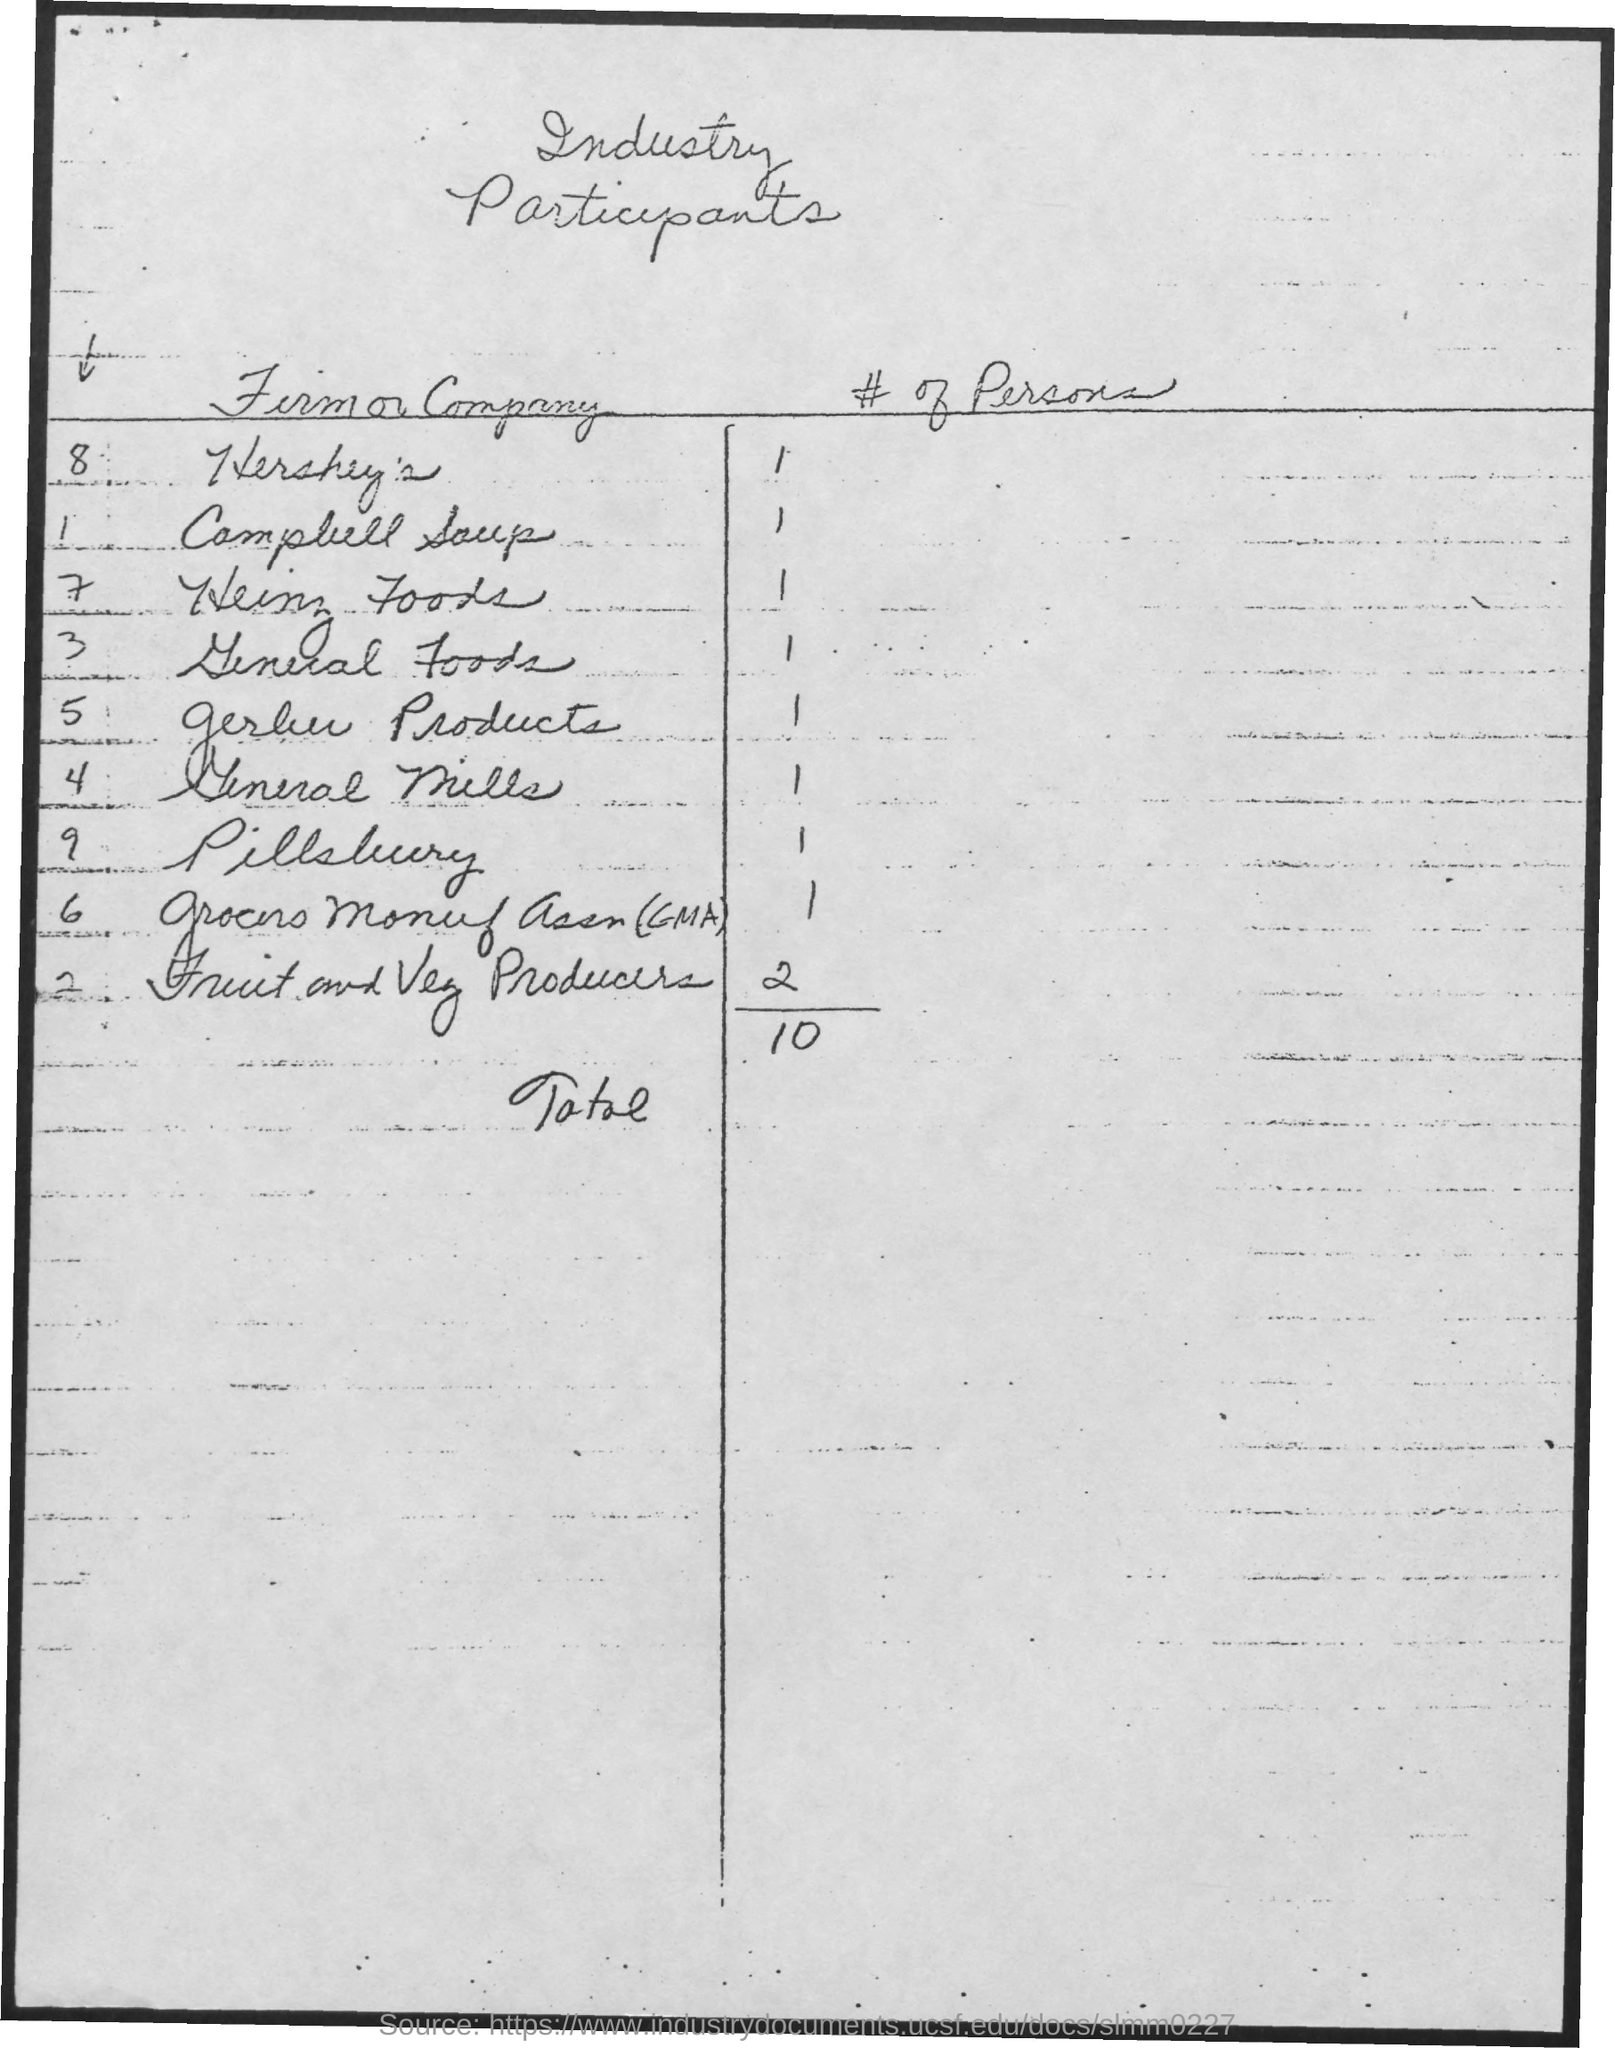Give some essential details in this illustration. Fruit and vegetable producers have the most number of participants compared to any other firm or company. There are a total of 10 participants. The table title is "Table of Industry Participants in the Solar Market. 